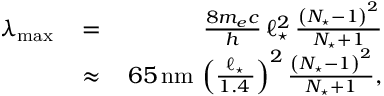<formula> <loc_0><loc_0><loc_500><loc_500>\begin{array} { r l r } { \lambda _ { \max } \, } & { = } & { \, \frac { 8 m _ { e } c } { h } \, \ell _ { ^ { * } } ^ { 2 } \, \frac { \left ( N _ { ^ { * } } - 1 \right ) ^ { 2 } } { N _ { ^ { * } } + 1 } } \\ & { \approx } & { \, 6 5 \, n m \, \left ( \frac { \ell _ { ^ { * } } } { 1 . 4 \, \AA } \right ) ^ { 2 } \frac { \left ( N _ { ^ { * } } - 1 \right ) ^ { 2 } } { N _ { ^ { * } } + 1 } , } \end{array}</formula> 